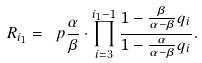<formula> <loc_0><loc_0><loc_500><loc_500>R _ { i _ { 1 } } = \ p { \frac { \alpha } { \beta } } \cdot \prod _ { i = 3 } ^ { i _ { 1 } - 1 } \frac { 1 - \frac { \beta } { \alpha - \beta } q _ { i } } { 1 - \frac { \alpha } { \alpha - \beta } q _ { i } } .</formula> 